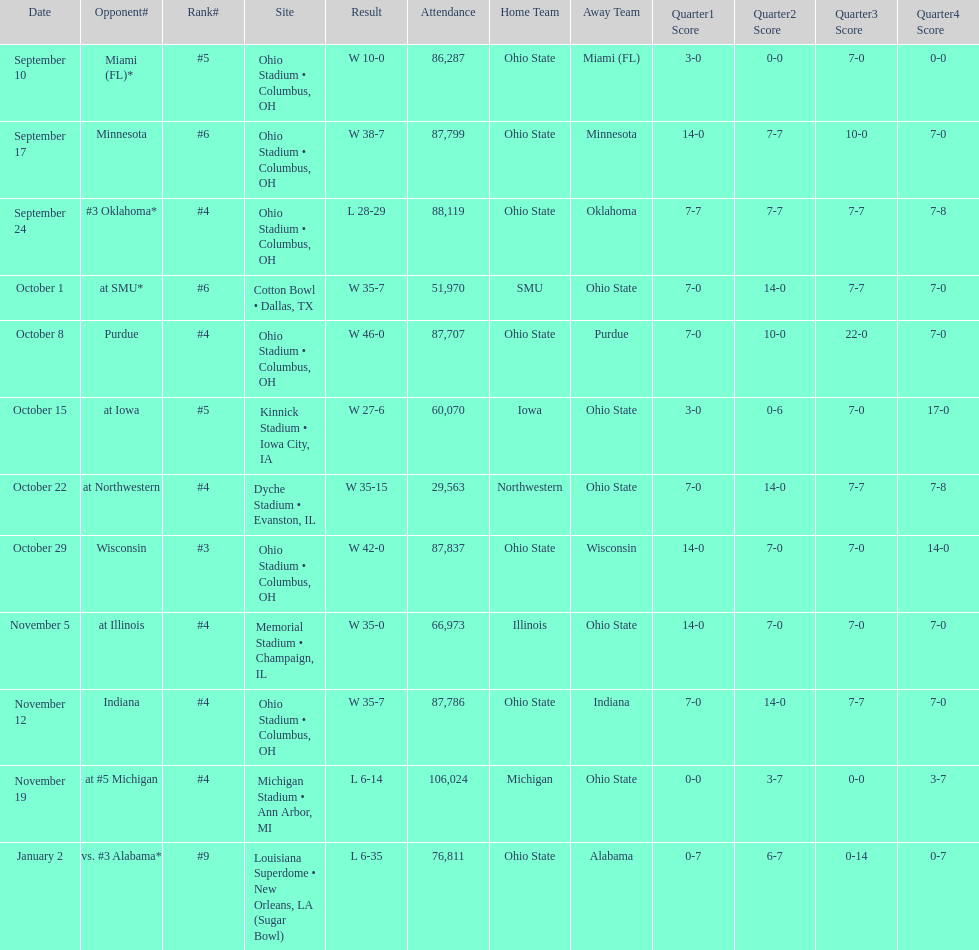When was the date with the maximum attendance? November 19. 